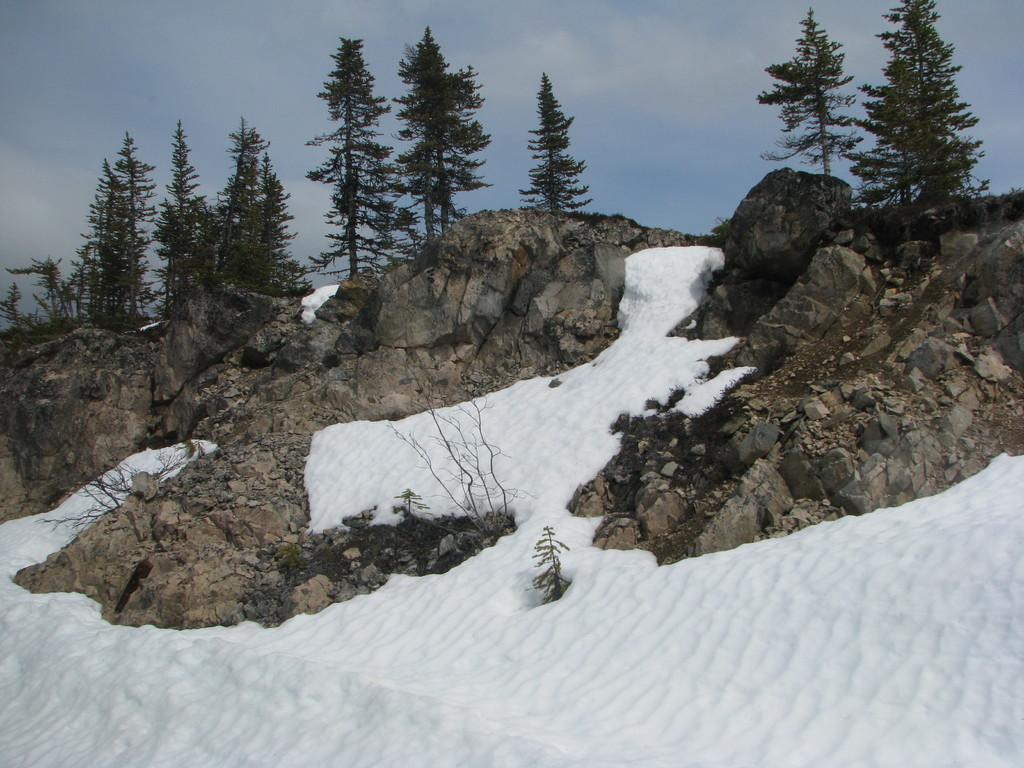What is covering the ground in the image? There is snow on the ground in the image. What type of natural objects can be seen in the image? There are stones and trees visible in the image. What is visible in the sky in the image? There are clouds visible in the sky in the image. Is there a veil covering the trees in the image? No, there is no veil present in the image. What type of waves can be seen in the image? There are no waves visible in the image, as it features a snowy landscape with trees and stones. 